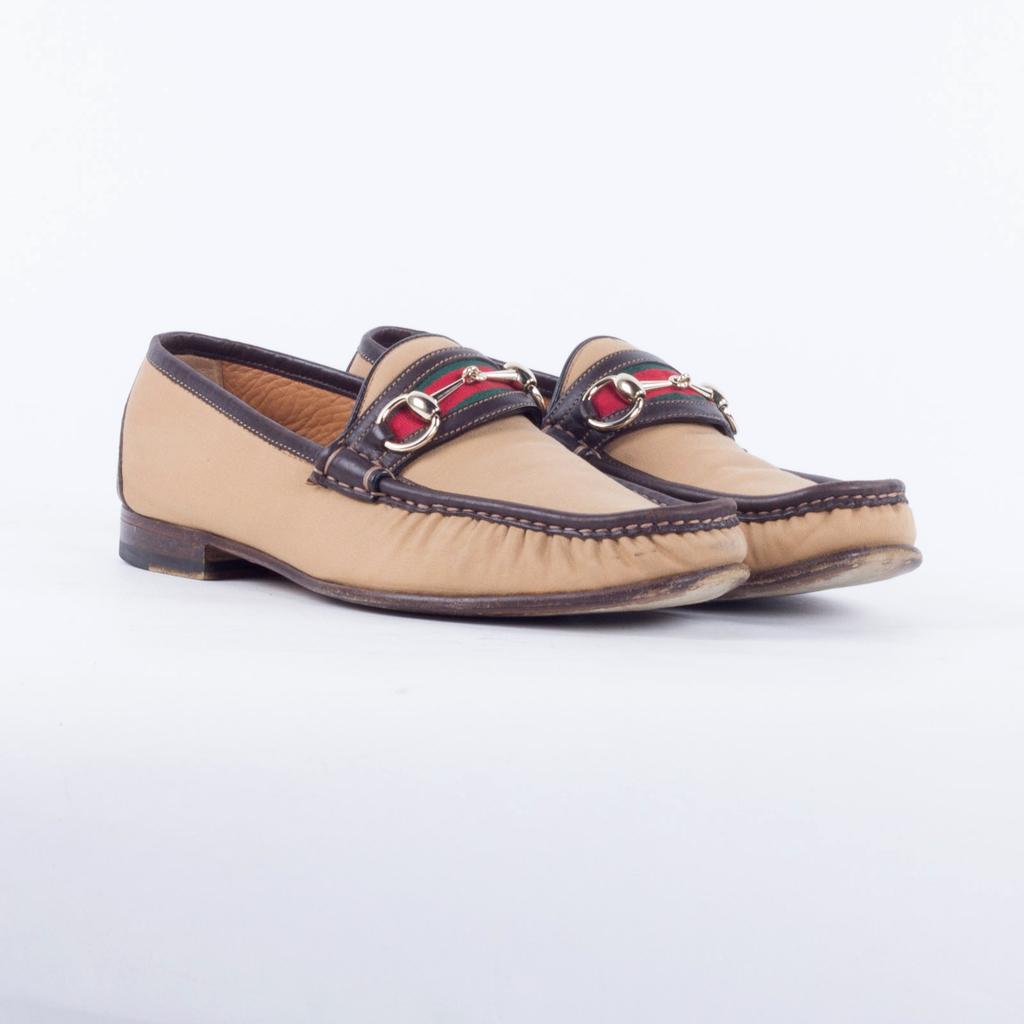Could you give a brief overview of what you see in this image? In the image we can see some shoes. 